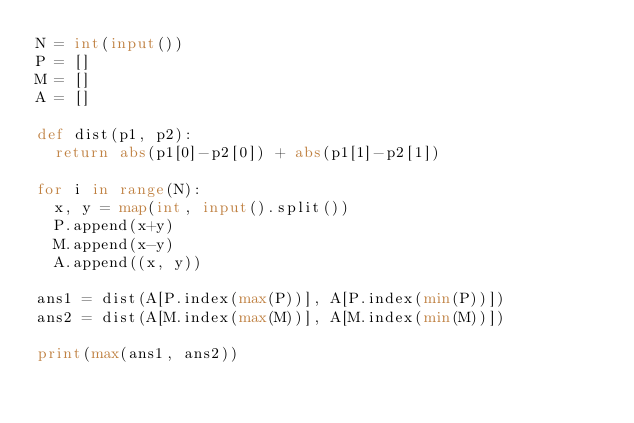<code> <loc_0><loc_0><loc_500><loc_500><_Python_>N = int(input())
P = []
M = []
A = []

def dist(p1, p2):
  return abs(p1[0]-p2[0]) + abs(p1[1]-p2[1])

for i in range(N):
  x, y = map(int, input().split())
  P.append(x+y)
  M.append(x-y)
  A.append((x, y))

ans1 = dist(A[P.index(max(P))], A[P.index(min(P))])
ans2 = dist(A[M.index(max(M))], A[M.index(min(M))])

print(max(ans1, ans2))</code> 